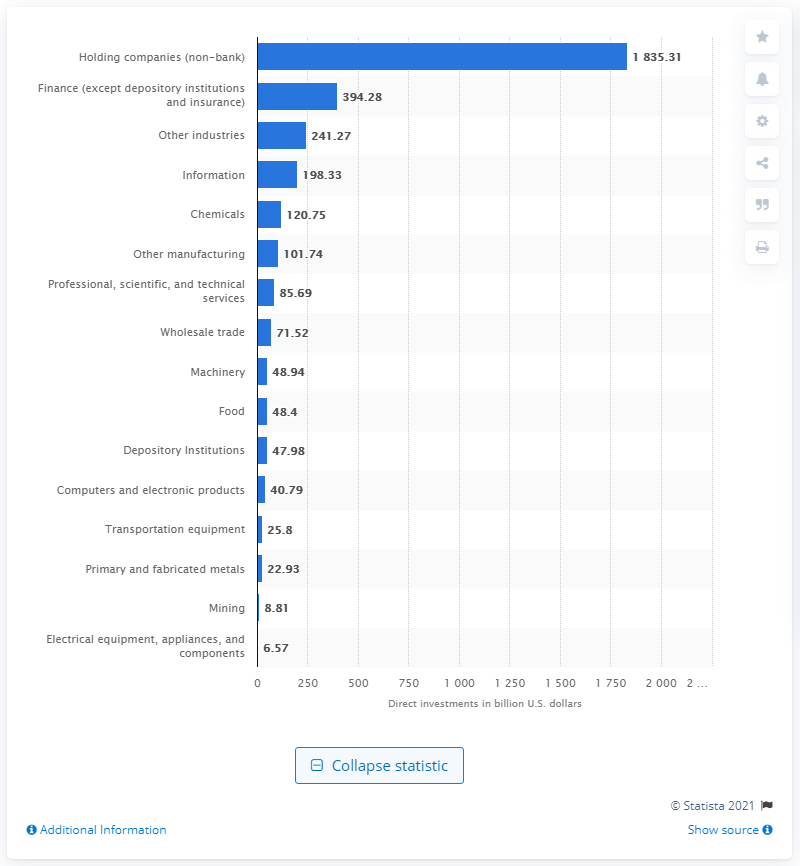Specify some key components in this picture. In 2019, the United States invested a total of $120.75 million in the chemicals industry in the European Union. 